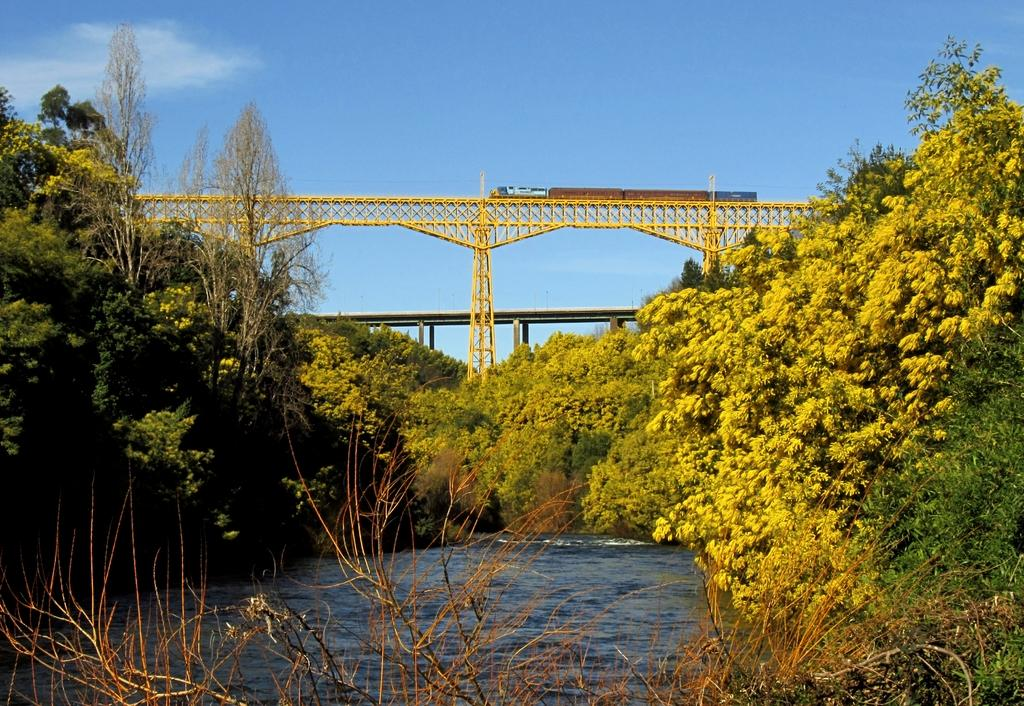What is the main feature of the image? The main feature of the image is a railway bridge with a train on it. What can be seen in the water in the image? There are no specific details about the water in the image. What type of vegetation is present in the image? There are trees in the image. What is visible in the background of the image? There is another bridge and the sky visible in the background of the image. What type of basin is used to collect water from the train in the image? There is no basin present in the image, nor is there any indication that water is being collected from the train. 